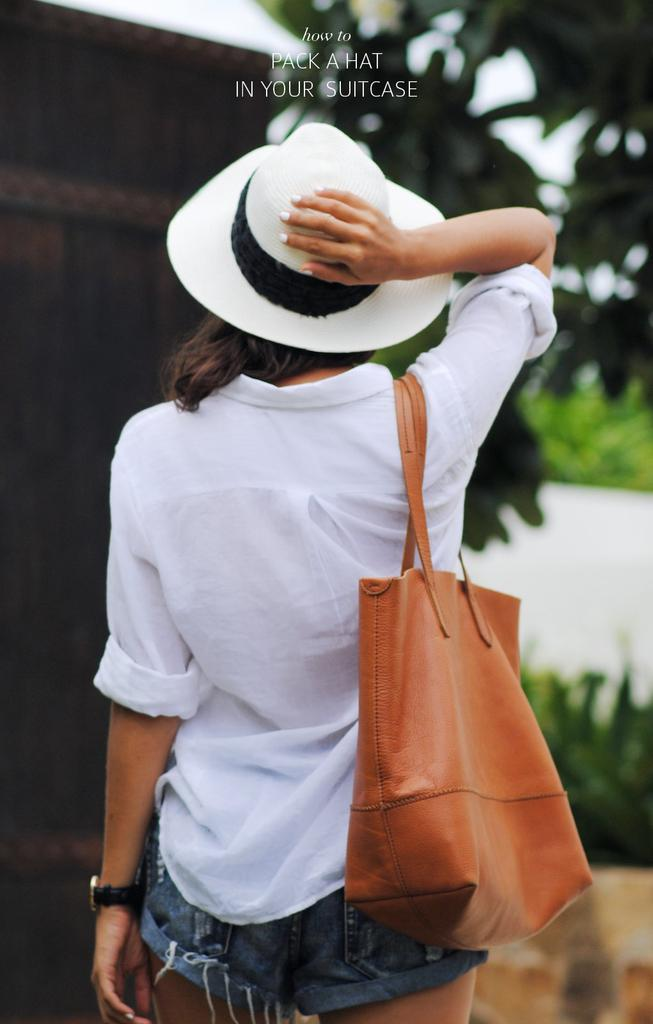What is the main subject of the image? The main subject of the image is a woman. What is the title of the image? The title of the image is "how to pack a hat in suitcase". What is the woman wearing on her head? The woman is wearing a white color hat. What is the woman holding in the image? The woman is holding a leather bag. How many bells can be seen hanging from the hat in the image? There are no bells visible in the image; the woman is wearing a white color hat. Can you tell me how many lizards are crawling on the woman's shirt in the image? There are no lizards present in the image; the woman is wearing a white shirt. 